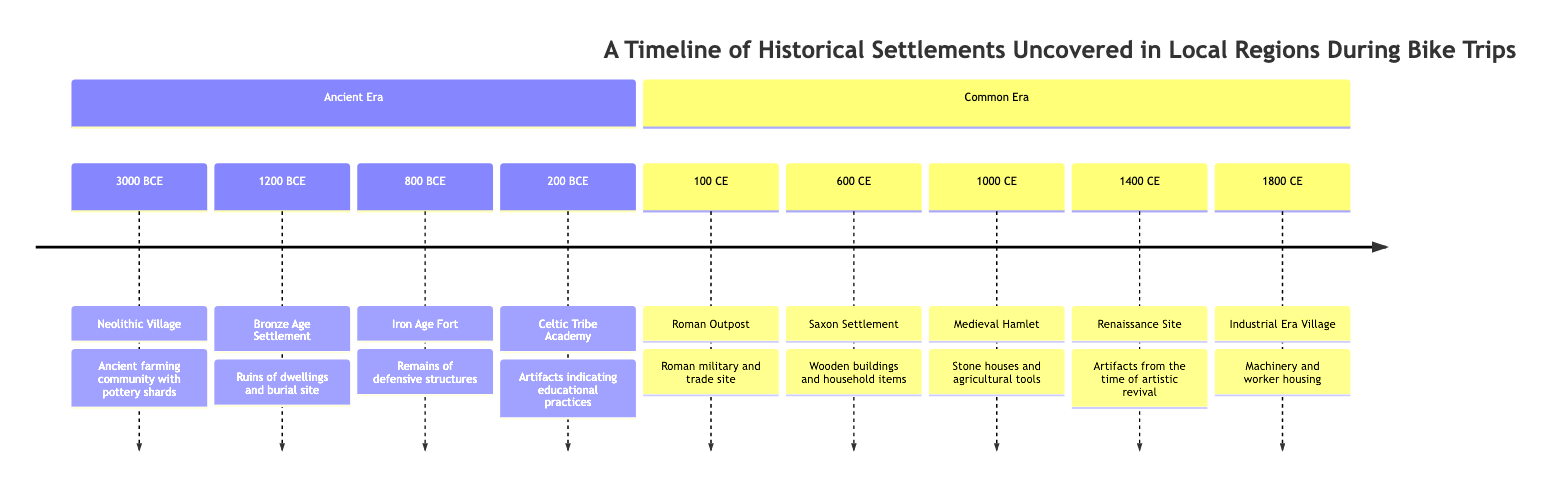What is the earliest settlement depicted on the timeline? The earliest settlement shown on the timeline is the Neolithic Village, which dates back to 3000 BCE. I identify this by reading the entries listed under the "Ancient Era" of the timeline, where I see that the first recorded settlement is Neolithic Village at the topmost position with the year 3000 BCE.
Answer: Neolithic Village Which settlement marks the transition between the Ancient Era and the Common Era? The settlement that marks the transition between the Ancient Era and the Common Era is the Roman Outpost, which is listed as occurring in 100 CE. This is determined by locating the boundary between the two eras in the diagram, where the Ancient Era ends and the Common Era begins, directly following the timeline's organization.
Answer: Roman Outpost How many settlements are there in the Common Era section? There are five settlements in the Common Era section. I count each entry listed under the "Common Era" section, noting the years and names of the settlements, which gives me a total of five distinct settlements.
Answer: 5 Which settlement has artifacts indicating educational practices? The settlement with artifacts indicating educational practices is the Celtic Tribe Academy, dated at 200 BCE. I find this information by looking through the descriptions of each settlement under the "Ancient Era," where the Celtic Tribe Academy is specifically mentioned for its educational artifacts.
Answer: Celtic Tribe Academy What type of structures are present in the Saxon Settlement? The Saxon Settlement contains wooden buildings. I determine this by referencing the description associated with the Saxon Settlement in the diagram, which explicitly states "Wooden buildings and household items."
Answer: Wooden buildings What significant change occurred between the settlements of 1000 CE and 1400 CE? The significant change between the settlements of 1000 CE (Medieval Hamlet) and 1400 CE (Renaissance Site) is the transition from a Medieval setting to a Renaissance context. By examining the descriptions of each settlement, I note the contrast in cultural and architectural characteristics, indicating a shift in societal values and aesthetics from medieval to artistic revival.
Answer: Cultural shift How many types of settlements are categorized in the Ancient Era? There are four types of settlements categorized in the Ancient Era. I verify this by counting the individual settlements listed under the "Ancient Era" section of the timeline, which are Neolithic Village, Bronze Age Settlement, Iron Age Fort, and Celtic Tribe Academy.
Answer: 4 What year does the Industrial Era Village date to? The Industrial Era Village dates to 1800 CE, which is clearly indicated in the "Common Era" section of the timeline. I look for the specific entry that provides the year and name, confirming that it falls in the later part of the timeline's listed events.
Answer: 1800 CE 